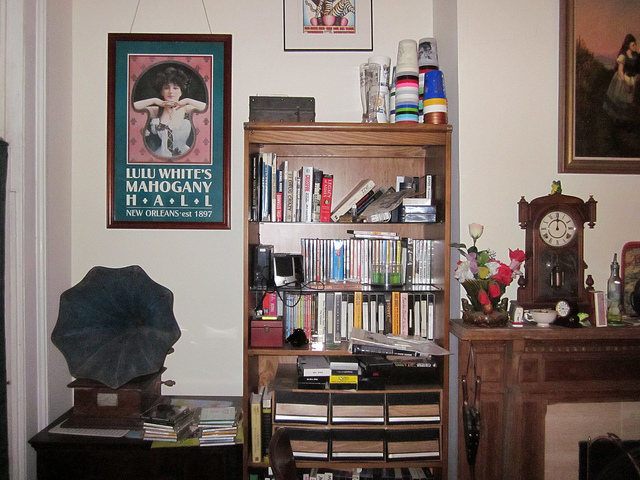Identify the text contained in this image. LULU WHITE'S MAHOGANY H A L L NLW ORLEANS'est 1897 VII XI X VI III XII 